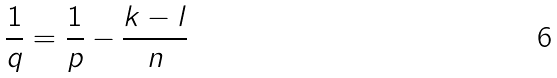<formula> <loc_0><loc_0><loc_500><loc_500>\frac { 1 } { q } = \frac { 1 } { p } - \frac { k - l } { n }</formula> 